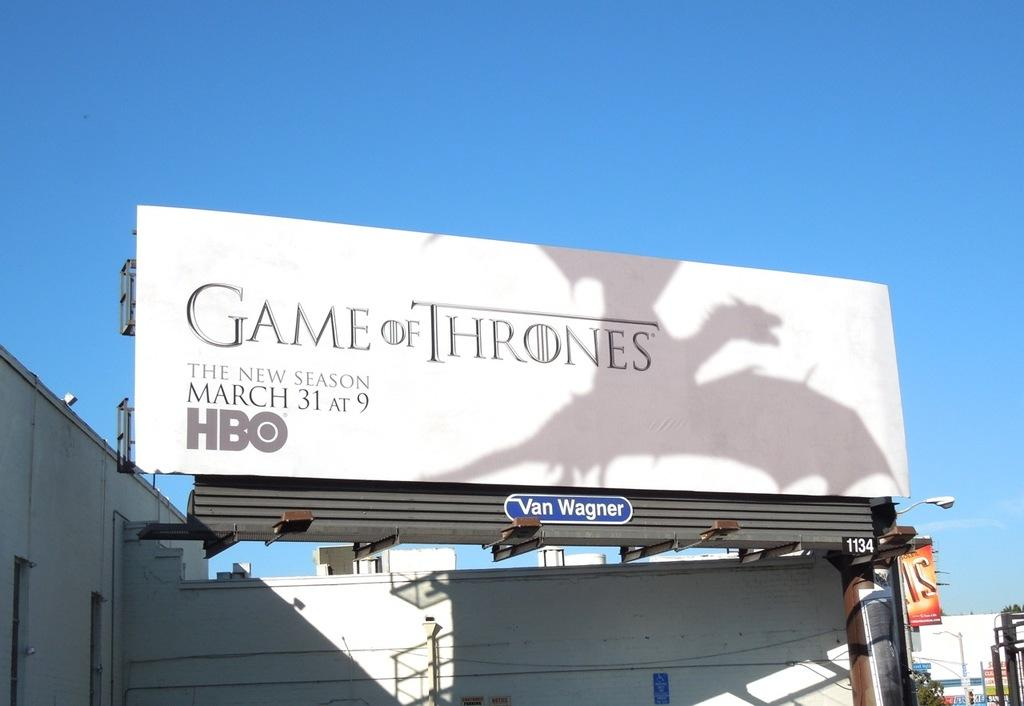<image>
Offer a succinct explanation of the picture presented. A billboard tells you that Game of Thrones new season starts March 31st at 9 am on HBO. 